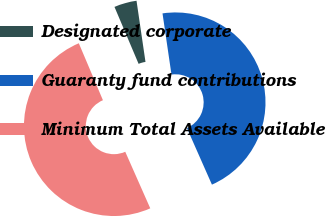<chart> <loc_0><loc_0><loc_500><loc_500><pie_chart><fcel>Designated corporate<fcel>Guaranty fund contributions<fcel>Minimum Total Assets Available<nl><fcel>4.06%<fcel>45.69%<fcel>50.25%<nl></chart> 